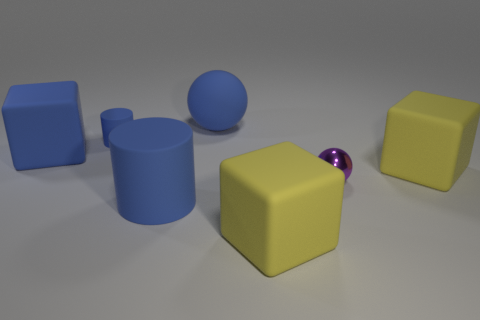Add 1 big blue matte cubes. How many objects exist? 8 Subtract all large blue blocks. How many blocks are left? 2 Subtract all blue blocks. How many blocks are left? 2 Subtract all cylinders. How many objects are left? 5 Subtract all blue blocks. Subtract all cyan spheres. How many blocks are left? 2 Subtract all purple cubes. How many purple balls are left? 1 Subtract all metal cubes. Subtract all big blue cylinders. How many objects are left? 6 Add 7 blue matte cylinders. How many blue matte cylinders are left? 9 Add 2 red shiny objects. How many red shiny objects exist? 2 Subtract 0 cyan cylinders. How many objects are left? 7 